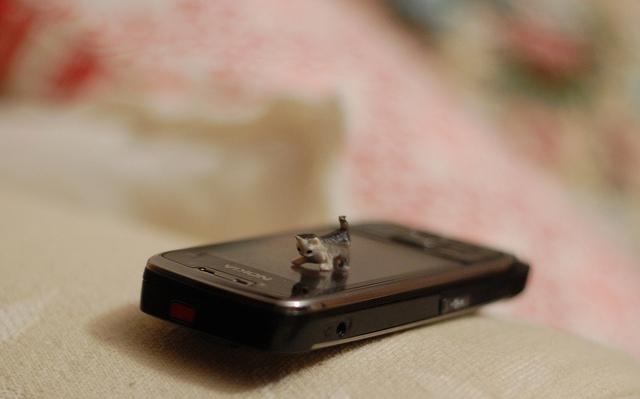Based on the phone size about what size is the cat sculpture? Please explain your reasoning. 1/2 inch. It's really a tiny cat sculpture. 